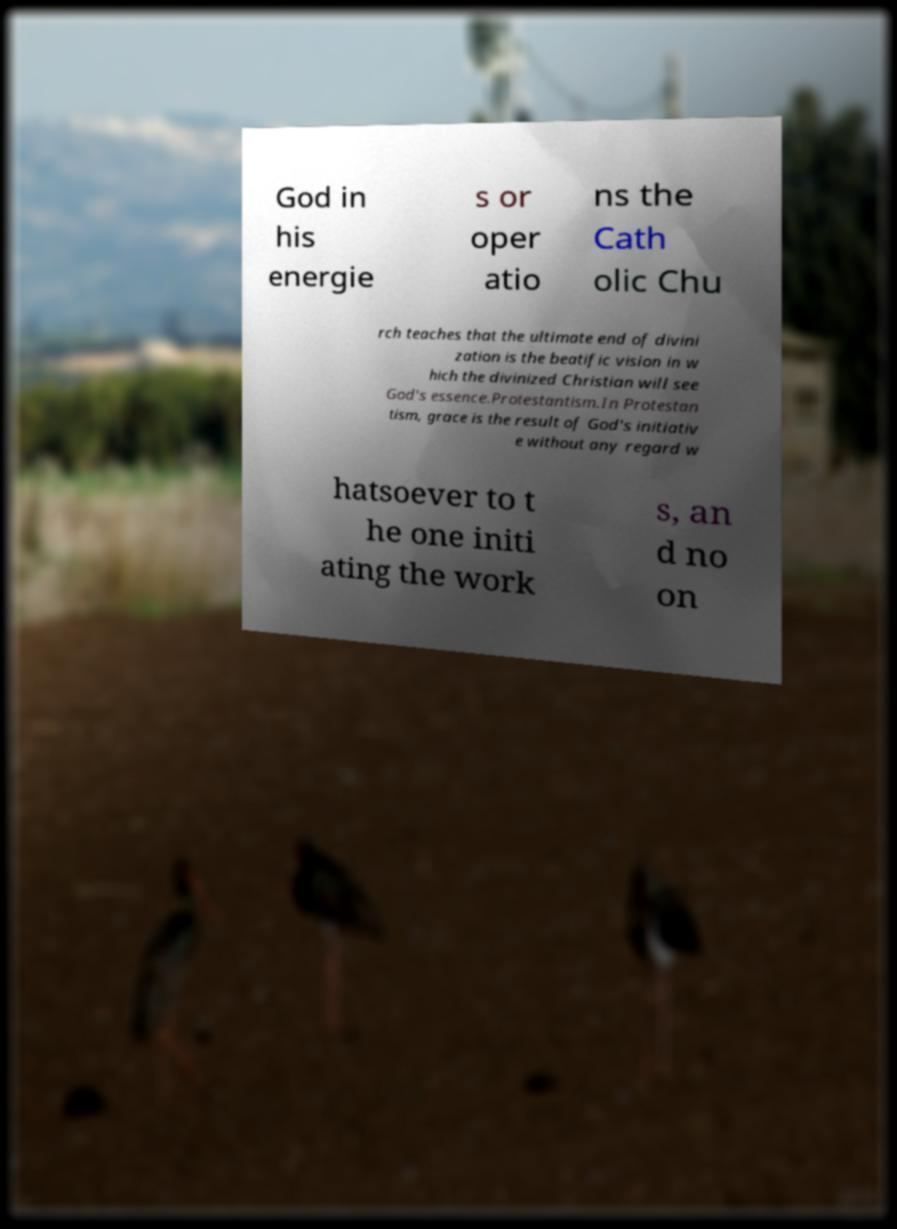Please identify and transcribe the text found in this image. God in his energie s or oper atio ns the Cath olic Chu rch teaches that the ultimate end of divini zation is the beatific vision in w hich the divinized Christian will see God's essence.Protestantism.In Protestan tism, grace is the result of God's initiativ e without any regard w hatsoever to t he one initi ating the work s, an d no on 